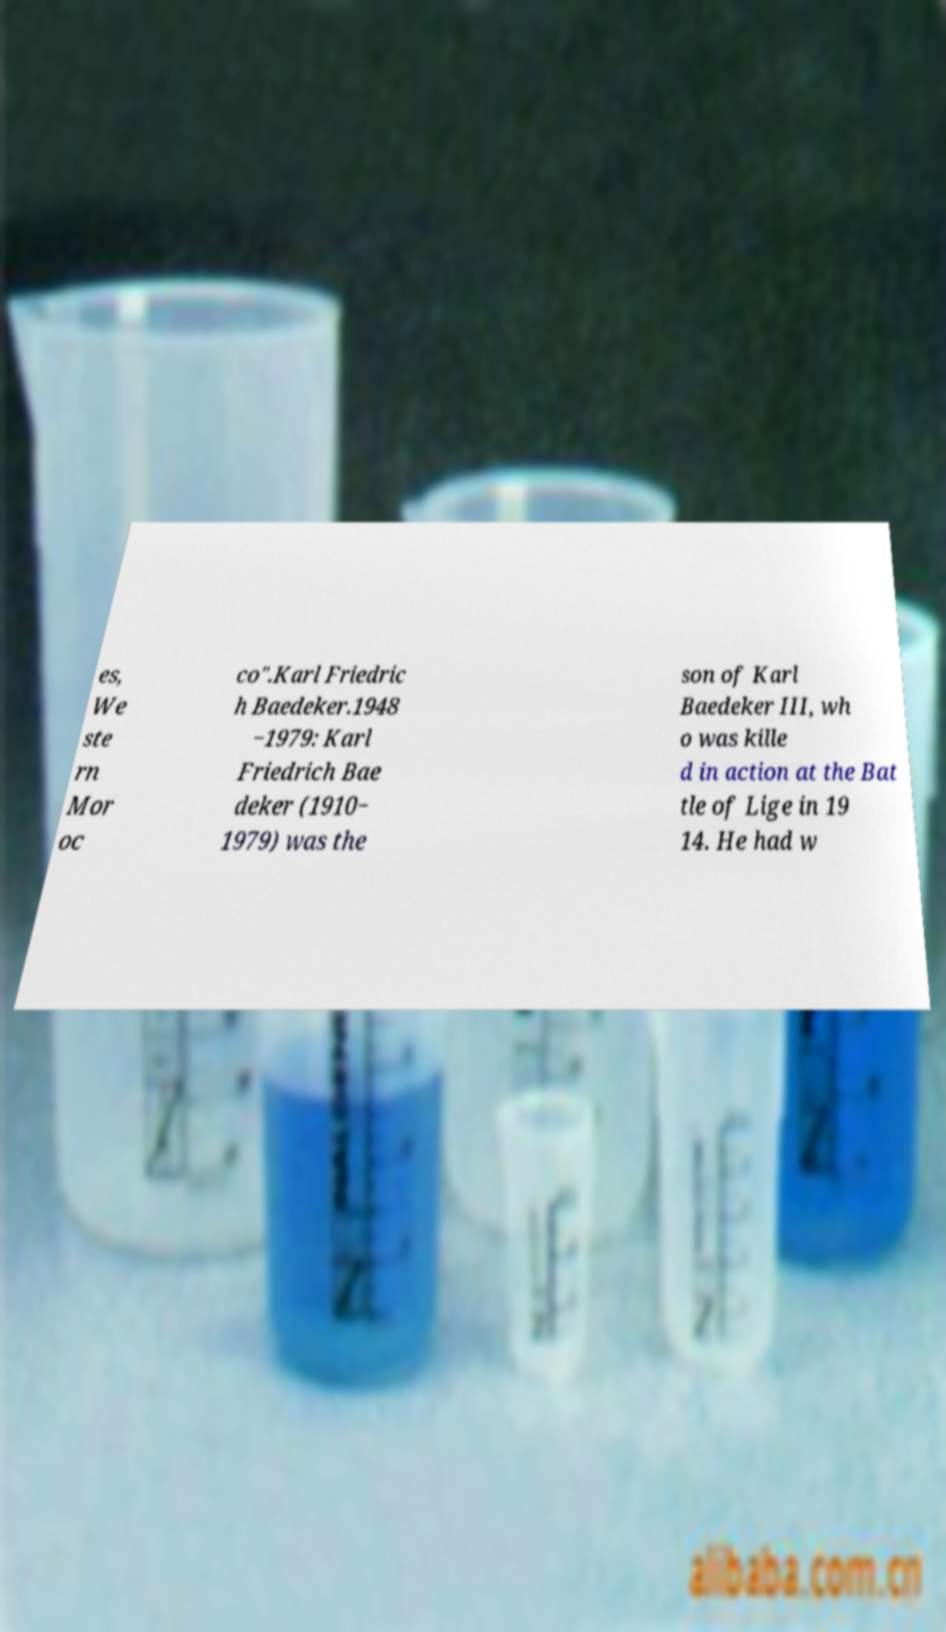There's text embedded in this image that I need extracted. Can you transcribe it verbatim? es, We ste rn Mor oc co".Karl Friedric h Baedeker.1948 −1979: Karl Friedrich Bae deker (1910− 1979) was the son of Karl Baedeker III, wh o was kille d in action at the Bat tle of Lige in 19 14. He had w 